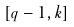Convert formula to latex. <formula><loc_0><loc_0><loc_500><loc_500>[ q - 1 , k ]</formula> 